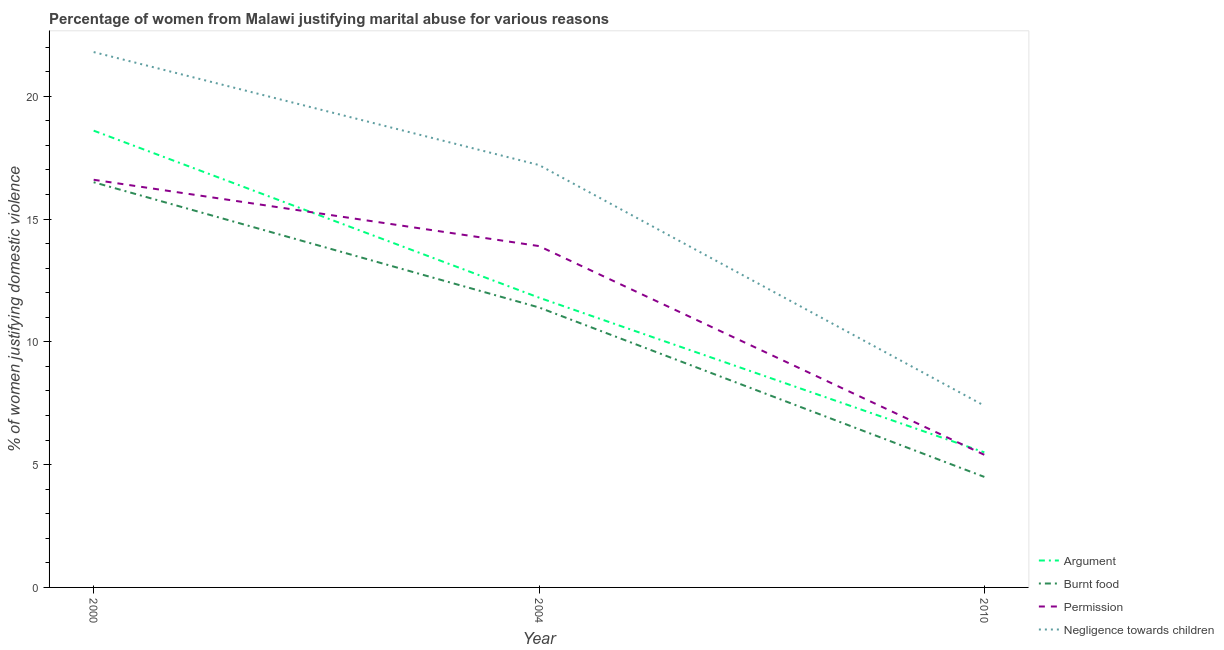How many different coloured lines are there?
Provide a short and direct response. 4. What is the percentage of women justifying abuse for showing negligence towards children in 2000?
Your answer should be very brief. 21.8. Across all years, what is the maximum percentage of women justifying abuse for showing negligence towards children?
Offer a terse response. 21.8. Across all years, what is the minimum percentage of women justifying abuse for showing negligence towards children?
Your answer should be very brief. 7.4. In which year was the percentage of women justifying abuse for showing negligence towards children maximum?
Offer a very short reply. 2000. What is the total percentage of women justifying abuse for showing negligence towards children in the graph?
Make the answer very short. 46.4. What is the difference between the percentage of women justifying abuse for burning food in 2004 and that in 2010?
Your answer should be very brief. 6.9. What is the difference between the percentage of women justifying abuse for going without permission in 2000 and the percentage of women justifying abuse for showing negligence towards children in 2010?
Your response must be concise. 9.2. What is the average percentage of women justifying abuse for showing negligence towards children per year?
Your answer should be compact. 15.47. In the year 2004, what is the difference between the percentage of women justifying abuse for showing negligence towards children and percentage of women justifying abuse in the case of an argument?
Give a very brief answer. 5.4. What is the ratio of the percentage of women justifying abuse for burning food in 2000 to that in 2004?
Keep it short and to the point. 1.45. What is the difference between the highest and the second highest percentage of women justifying abuse for burning food?
Give a very brief answer. 5.1. Is the sum of the percentage of women justifying abuse for going without permission in 2000 and 2010 greater than the maximum percentage of women justifying abuse in the case of an argument across all years?
Offer a very short reply. Yes. Is it the case that in every year, the sum of the percentage of women justifying abuse in the case of an argument and percentage of women justifying abuse for burning food is greater than the sum of percentage of women justifying abuse for going without permission and percentage of women justifying abuse for showing negligence towards children?
Your answer should be compact. No. Is it the case that in every year, the sum of the percentage of women justifying abuse in the case of an argument and percentage of women justifying abuse for burning food is greater than the percentage of women justifying abuse for going without permission?
Offer a terse response. Yes. Does the percentage of women justifying abuse for burning food monotonically increase over the years?
Make the answer very short. No. How many lines are there?
Provide a succinct answer. 4. What is the difference between two consecutive major ticks on the Y-axis?
Give a very brief answer. 5. Does the graph contain grids?
Your answer should be compact. No. How many legend labels are there?
Provide a short and direct response. 4. What is the title of the graph?
Provide a succinct answer. Percentage of women from Malawi justifying marital abuse for various reasons. Does "Agricultural land" appear as one of the legend labels in the graph?
Your answer should be very brief. No. What is the label or title of the Y-axis?
Give a very brief answer. % of women justifying domestic violence. What is the % of women justifying domestic violence of Argument in 2000?
Keep it short and to the point. 18.6. What is the % of women justifying domestic violence of Negligence towards children in 2000?
Provide a short and direct response. 21.8. What is the % of women justifying domestic violence in Burnt food in 2004?
Keep it short and to the point. 11.4. What is the % of women justifying domestic violence of Burnt food in 2010?
Ensure brevity in your answer.  4.5. What is the % of women justifying domestic violence in Permission in 2010?
Give a very brief answer. 5.4. What is the % of women justifying domestic violence in Negligence towards children in 2010?
Keep it short and to the point. 7.4. Across all years, what is the maximum % of women justifying domestic violence in Argument?
Your answer should be compact. 18.6. Across all years, what is the maximum % of women justifying domestic violence in Negligence towards children?
Offer a very short reply. 21.8. Across all years, what is the minimum % of women justifying domestic violence in Argument?
Offer a very short reply. 5.5. What is the total % of women justifying domestic violence of Argument in the graph?
Offer a very short reply. 35.9. What is the total % of women justifying domestic violence of Burnt food in the graph?
Make the answer very short. 32.4. What is the total % of women justifying domestic violence in Permission in the graph?
Provide a short and direct response. 35.9. What is the total % of women justifying domestic violence of Negligence towards children in the graph?
Ensure brevity in your answer.  46.4. What is the difference between the % of women justifying domestic violence in Argument in 2000 and that in 2004?
Give a very brief answer. 6.8. What is the difference between the % of women justifying domestic violence of Permission in 2000 and that in 2004?
Provide a succinct answer. 2.7. What is the difference between the % of women justifying domestic violence in Argument in 2000 and that in 2010?
Offer a terse response. 13.1. What is the difference between the % of women justifying domestic violence in Burnt food in 2000 and that in 2010?
Offer a very short reply. 12. What is the difference between the % of women justifying domestic violence in Argument in 2004 and that in 2010?
Your answer should be compact. 6.3. What is the difference between the % of women justifying domestic violence of Permission in 2004 and that in 2010?
Make the answer very short. 8.5. What is the difference between the % of women justifying domestic violence of Argument in 2000 and the % of women justifying domestic violence of Negligence towards children in 2004?
Offer a terse response. 1.4. What is the difference between the % of women justifying domestic violence of Burnt food in 2000 and the % of women justifying domestic violence of Permission in 2004?
Your response must be concise. 2.6. What is the difference between the % of women justifying domestic violence in Permission in 2000 and the % of women justifying domestic violence in Negligence towards children in 2004?
Your answer should be compact. -0.6. What is the difference between the % of women justifying domestic violence in Argument in 2000 and the % of women justifying domestic violence in Burnt food in 2010?
Give a very brief answer. 14.1. What is the difference between the % of women justifying domestic violence in Argument in 2000 and the % of women justifying domestic violence in Permission in 2010?
Make the answer very short. 13.2. What is the difference between the % of women justifying domestic violence of Burnt food in 2000 and the % of women justifying domestic violence of Permission in 2010?
Your response must be concise. 11.1. What is the difference between the % of women justifying domestic violence in Permission in 2000 and the % of women justifying domestic violence in Negligence towards children in 2010?
Provide a succinct answer. 9.2. What is the difference between the % of women justifying domestic violence of Argument in 2004 and the % of women justifying domestic violence of Negligence towards children in 2010?
Keep it short and to the point. 4.4. What is the average % of women justifying domestic violence of Argument per year?
Your answer should be compact. 11.97. What is the average % of women justifying domestic violence in Burnt food per year?
Your response must be concise. 10.8. What is the average % of women justifying domestic violence of Permission per year?
Make the answer very short. 11.97. What is the average % of women justifying domestic violence in Negligence towards children per year?
Ensure brevity in your answer.  15.47. In the year 2000, what is the difference between the % of women justifying domestic violence in Argument and % of women justifying domestic violence in Negligence towards children?
Offer a very short reply. -3.2. In the year 2000, what is the difference between the % of women justifying domestic violence of Permission and % of women justifying domestic violence of Negligence towards children?
Offer a very short reply. -5.2. In the year 2004, what is the difference between the % of women justifying domestic violence of Argument and % of women justifying domestic violence of Burnt food?
Your answer should be very brief. 0.4. In the year 2004, what is the difference between the % of women justifying domestic violence of Argument and % of women justifying domestic violence of Permission?
Your answer should be very brief. -2.1. In the year 2004, what is the difference between the % of women justifying domestic violence in Argument and % of women justifying domestic violence in Negligence towards children?
Your response must be concise. -5.4. In the year 2004, what is the difference between the % of women justifying domestic violence in Burnt food and % of women justifying domestic violence in Negligence towards children?
Ensure brevity in your answer.  -5.8. In the year 2004, what is the difference between the % of women justifying domestic violence in Permission and % of women justifying domestic violence in Negligence towards children?
Give a very brief answer. -3.3. In the year 2010, what is the difference between the % of women justifying domestic violence of Burnt food and % of women justifying domestic violence of Permission?
Keep it short and to the point. -0.9. In the year 2010, what is the difference between the % of women justifying domestic violence of Burnt food and % of women justifying domestic violence of Negligence towards children?
Your response must be concise. -2.9. What is the ratio of the % of women justifying domestic violence of Argument in 2000 to that in 2004?
Your response must be concise. 1.58. What is the ratio of the % of women justifying domestic violence of Burnt food in 2000 to that in 2004?
Keep it short and to the point. 1.45. What is the ratio of the % of women justifying domestic violence of Permission in 2000 to that in 2004?
Your answer should be compact. 1.19. What is the ratio of the % of women justifying domestic violence in Negligence towards children in 2000 to that in 2004?
Keep it short and to the point. 1.27. What is the ratio of the % of women justifying domestic violence in Argument in 2000 to that in 2010?
Provide a short and direct response. 3.38. What is the ratio of the % of women justifying domestic violence in Burnt food in 2000 to that in 2010?
Keep it short and to the point. 3.67. What is the ratio of the % of women justifying domestic violence of Permission in 2000 to that in 2010?
Provide a succinct answer. 3.07. What is the ratio of the % of women justifying domestic violence of Negligence towards children in 2000 to that in 2010?
Give a very brief answer. 2.95. What is the ratio of the % of women justifying domestic violence in Argument in 2004 to that in 2010?
Offer a very short reply. 2.15. What is the ratio of the % of women justifying domestic violence of Burnt food in 2004 to that in 2010?
Offer a very short reply. 2.53. What is the ratio of the % of women justifying domestic violence in Permission in 2004 to that in 2010?
Make the answer very short. 2.57. What is the ratio of the % of women justifying domestic violence in Negligence towards children in 2004 to that in 2010?
Your answer should be very brief. 2.32. What is the difference between the highest and the second highest % of women justifying domestic violence of Argument?
Make the answer very short. 6.8. What is the difference between the highest and the second highest % of women justifying domestic violence in Permission?
Make the answer very short. 2.7. What is the difference between the highest and the second highest % of women justifying domestic violence of Negligence towards children?
Give a very brief answer. 4.6. What is the difference between the highest and the lowest % of women justifying domestic violence in Burnt food?
Provide a short and direct response. 12. 